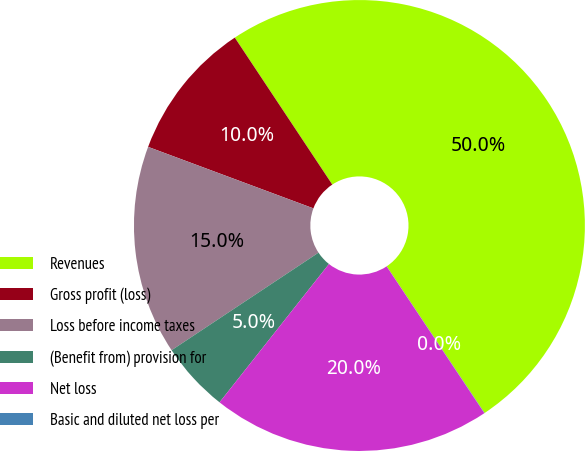Convert chart. <chart><loc_0><loc_0><loc_500><loc_500><pie_chart><fcel>Revenues<fcel>Gross profit (loss)<fcel>Loss before income taxes<fcel>(Benefit from) provision for<fcel>Net loss<fcel>Basic and diluted net loss per<nl><fcel>49.96%<fcel>10.01%<fcel>15.0%<fcel>5.02%<fcel>20.0%<fcel>0.02%<nl></chart> 